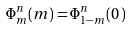Convert formula to latex. <formula><loc_0><loc_0><loc_500><loc_500>\Phi _ { m } ^ { n } ( m ) = \Phi _ { 1 - m } ^ { n } ( 0 \, ) \,</formula> 